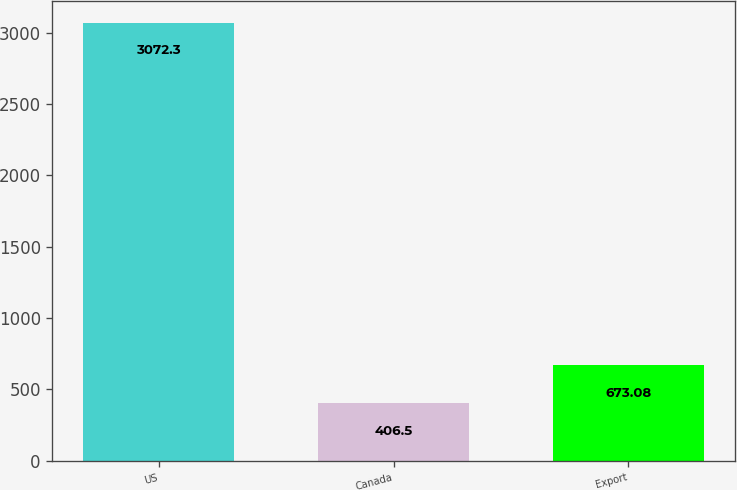Convert chart. <chart><loc_0><loc_0><loc_500><loc_500><bar_chart><fcel>US<fcel>Canada<fcel>Export<nl><fcel>3072.3<fcel>406.5<fcel>673.08<nl></chart> 